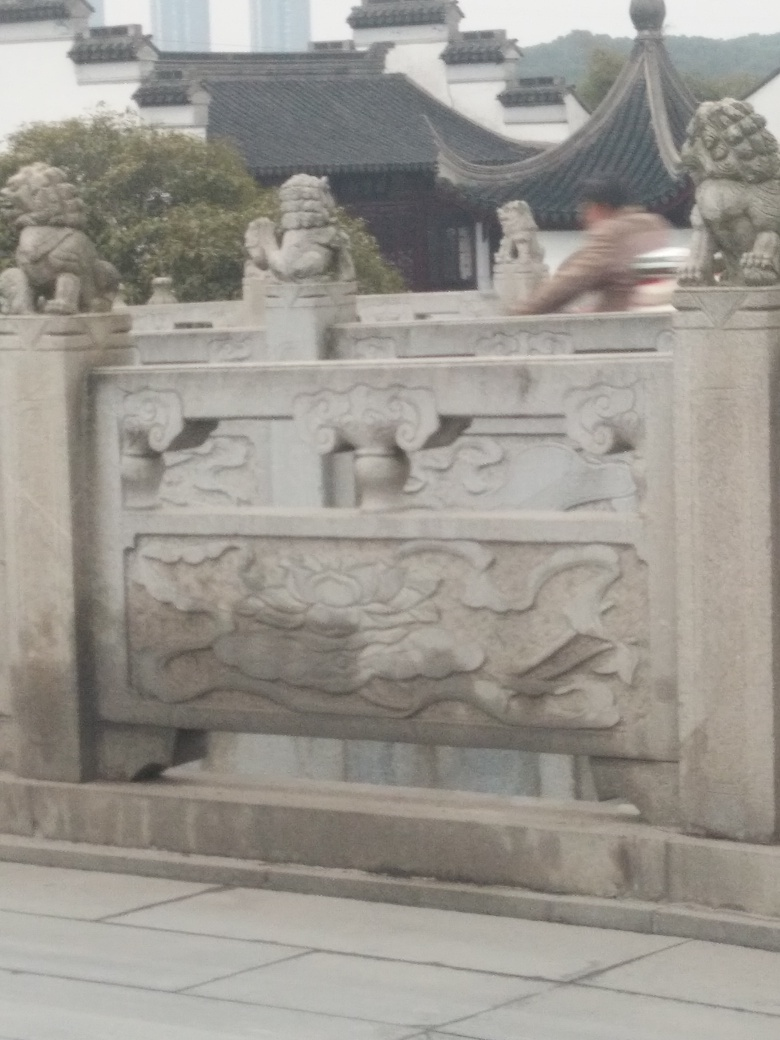Aside from the main subjects, is there anything else interesting about this image you can comment on? One interesting aspect of this image is the motion blur captured, likely a result of the camera moving during exposure or a fast-moving subject passing through the frame. This unintentional effect creates a sense of movement and haste, contrasting with the stillness and permanence of the stone constructions, adding a layer of dynamism to the otherwise static scene. 